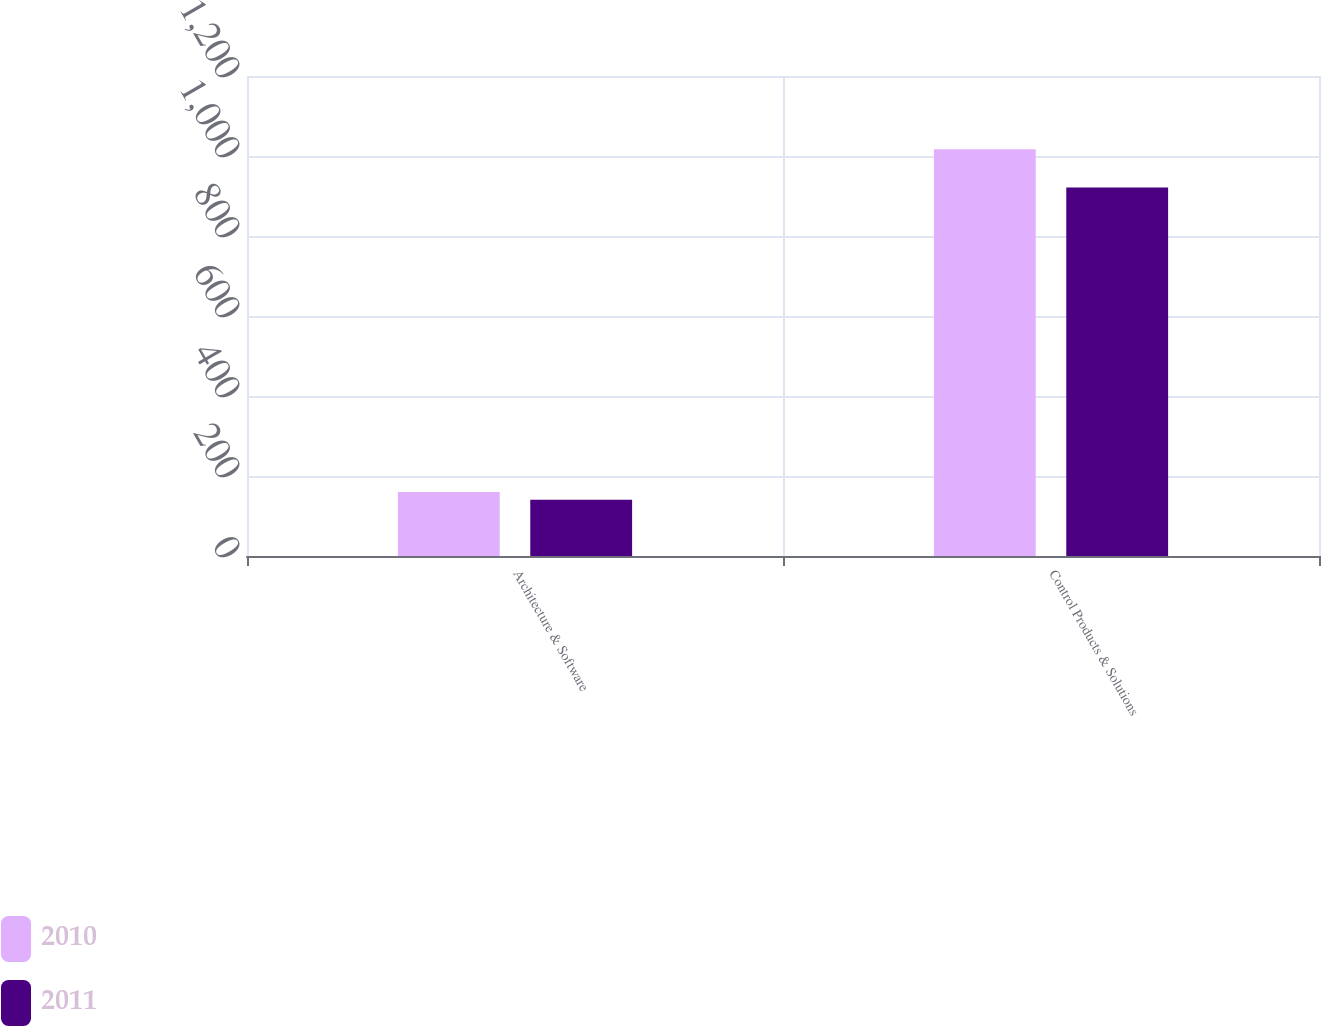Convert chart to OTSL. <chart><loc_0><loc_0><loc_500><loc_500><stacked_bar_chart><ecel><fcel>Architecture & Software<fcel>Control Products & Solutions<nl><fcel>2010<fcel>160.3<fcel>1016.8<nl><fcel>2011<fcel>140.6<fcel>921<nl></chart> 